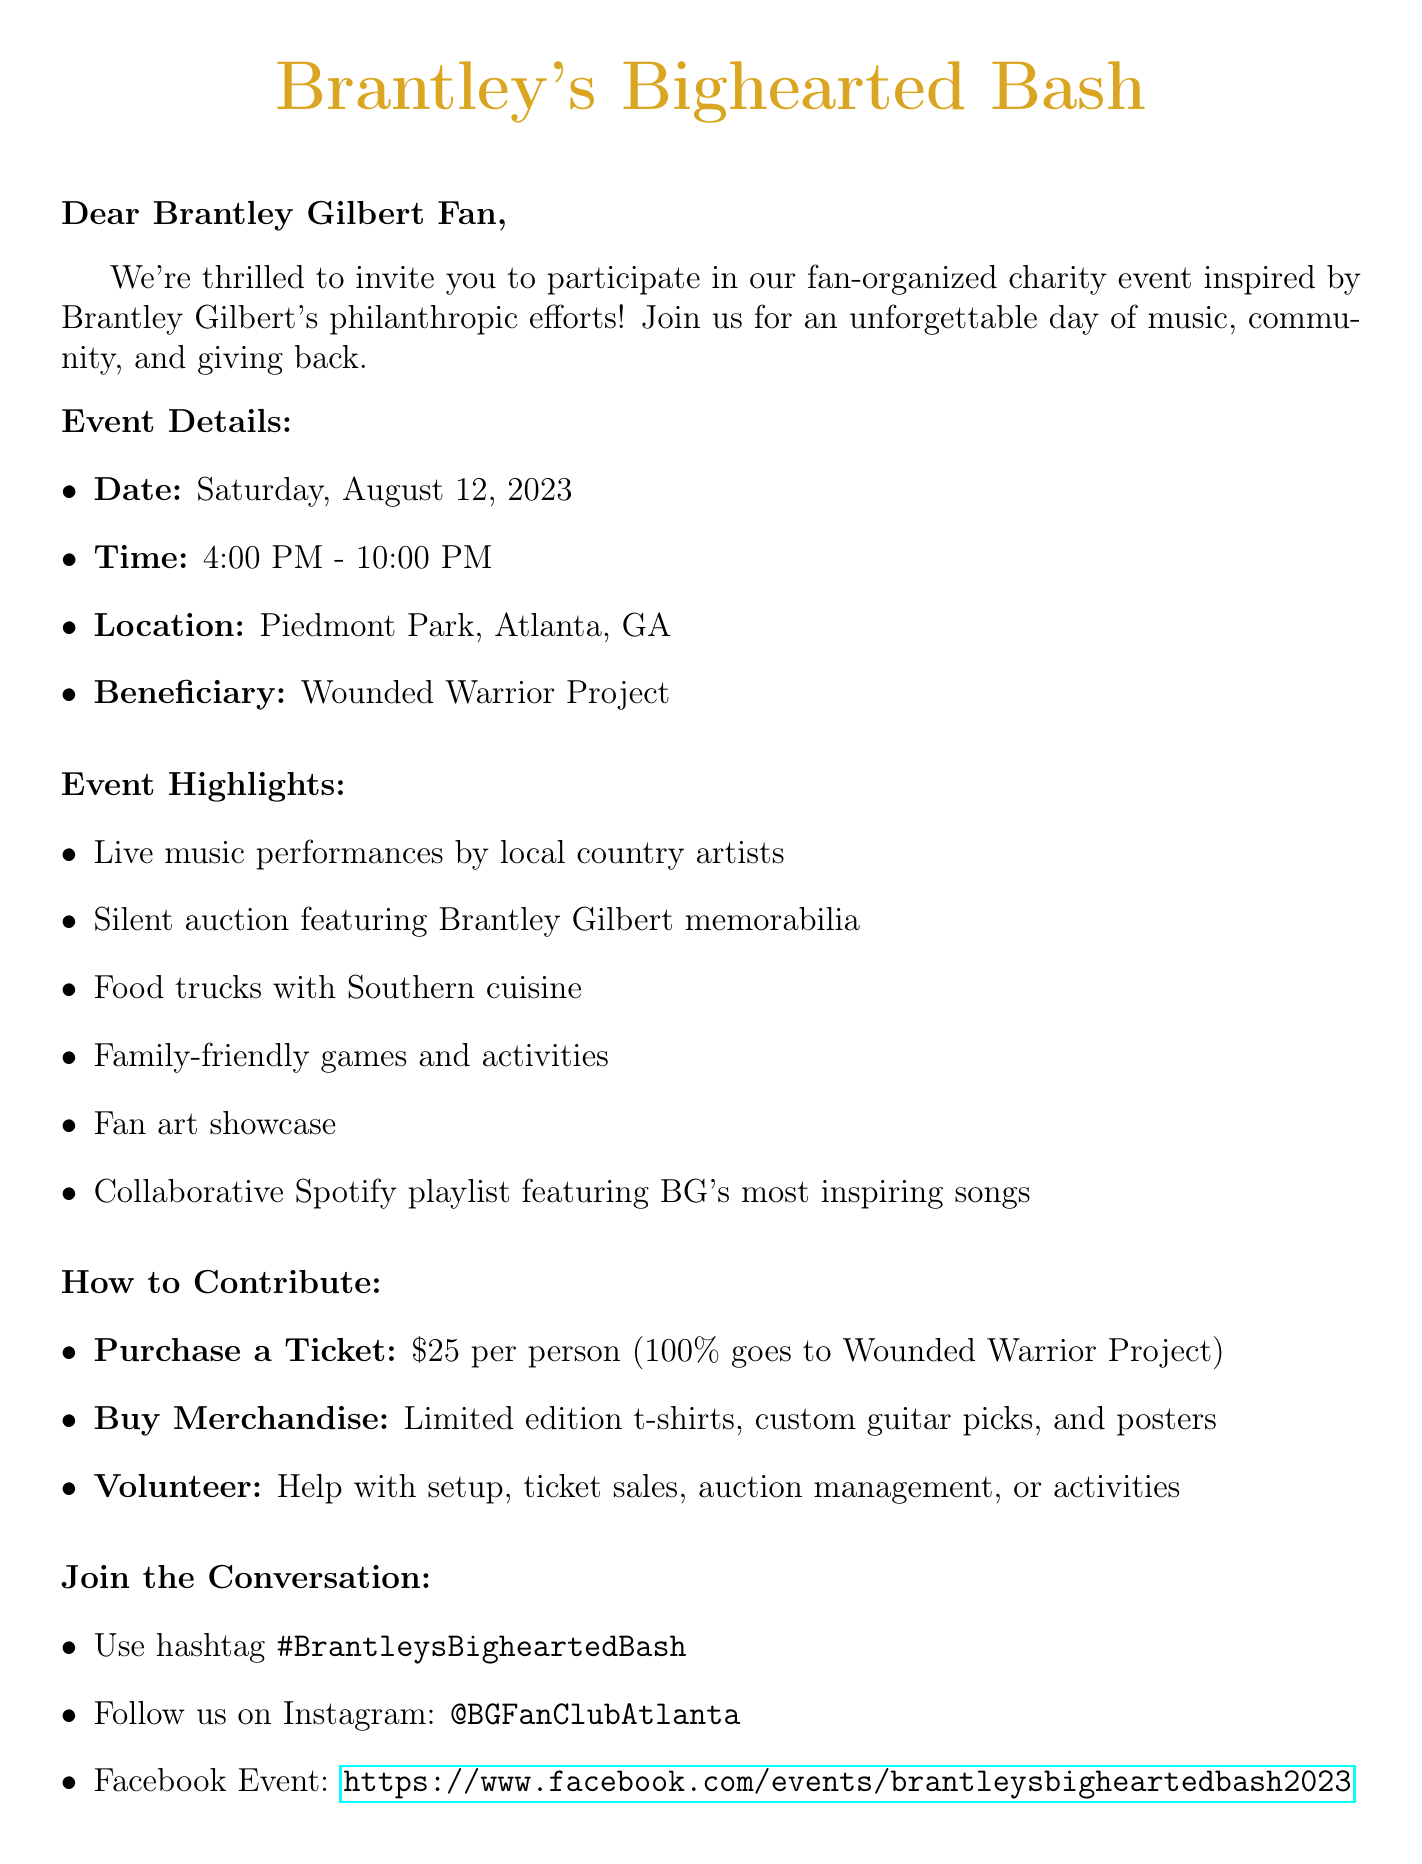What is the event name? The event name is mentioned in the document and is highlighted prominently.
Answer: Brantley's Bighearted Bash What is the date of the event? The date is specified in the event details section of the document.
Answer: Saturday, August 12, 2023 Who is the charity beneficiary? The charity beneficiary is stated in the event details and represents who will benefit from the event.
Answer: Wounded Warrior Project What time does the event start? The starting time is listed alongside the date in the event details section of the document.
Answer: 4:00 PM What is the price of a ticket? The ticket price is explicitly mentioned in the section describing how to contribute.
Answer: $25 per person What opportunities are available for volunteering? The document lists specific volunteer positions available for participants.
Answer: Event setup and teardown, Ticket sales, Silent auction management, Activity coordinators How can fans showcase their art at the event? The document describes a specific activity for art showcase by fans within the event highlights.
Answer: Display of Brantley Gilbert fan art at the event What is the registration link for the event? The registration link is included towards the end of the document.
Answer: https://www.eventbrite.com/brantleys-bighearted-bash-2023 Who is the organizer of the event? The document provides the name and role of the event organizer in the contact information section.
Answer: Jessica Thompson 